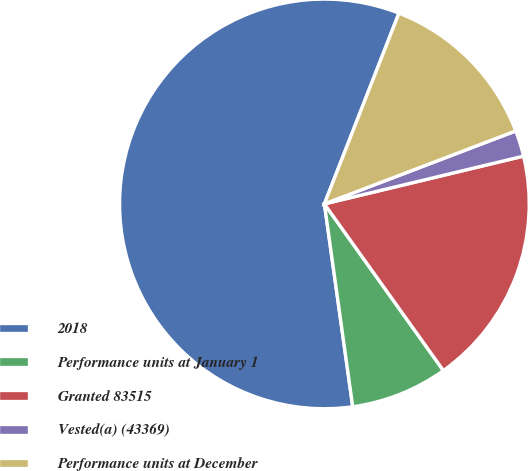Convert chart. <chart><loc_0><loc_0><loc_500><loc_500><pie_chart><fcel>2018<fcel>Performance units at January 1<fcel>Granted 83515<fcel>Vested(a) (43369)<fcel>Performance units at December<nl><fcel>58.14%<fcel>7.66%<fcel>18.88%<fcel>2.05%<fcel>13.27%<nl></chart> 